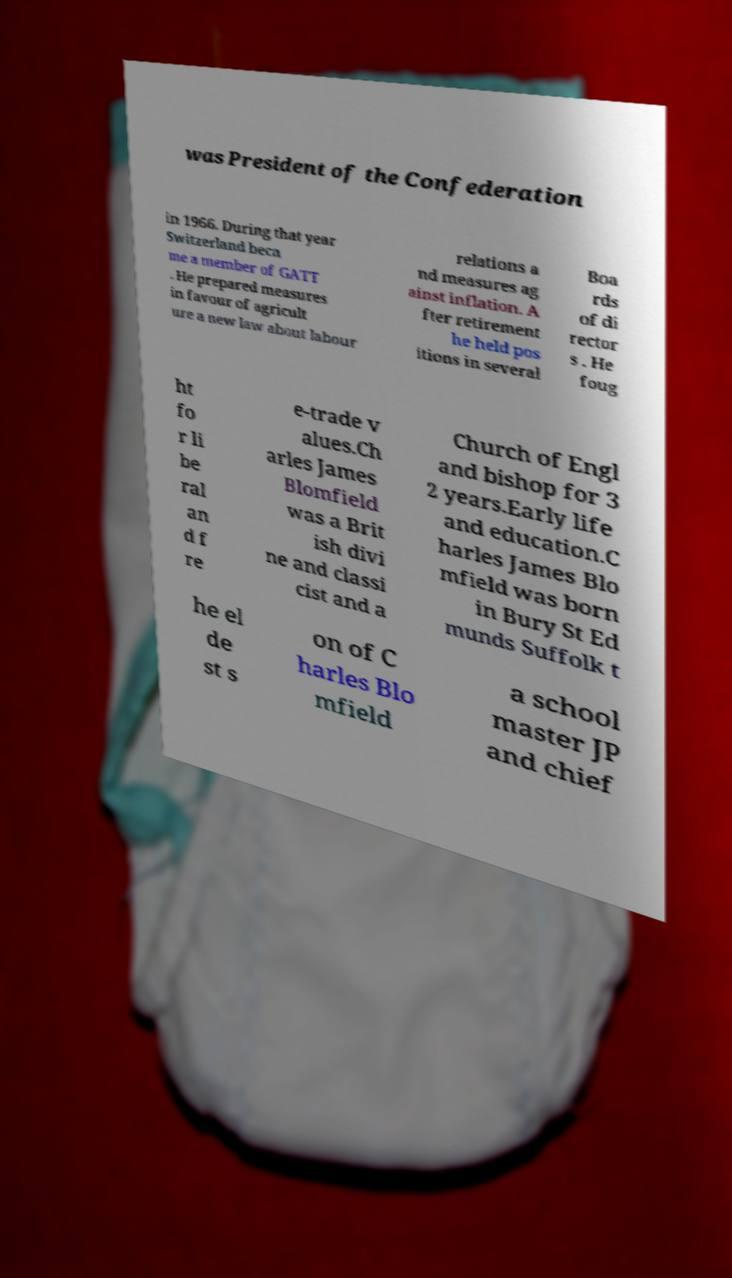Could you assist in decoding the text presented in this image and type it out clearly? was President of the Confederation in 1966. During that year Switzerland beca me a member of GATT . He prepared measures in favour of agricult ure a new law about labour relations a nd measures ag ainst inflation. A fter retirement he held pos itions in several Boa rds of di rector s . He foug ht fo r li be ral an d f re e-trade v alues.Ch arles James Blomfield was a Brit ish divi ne and classi cist and a Church of Engl and bishop for 3 2 years.Early life and education.C harles James Blo mfield was born in Bury St Ed munds Suffolk t he el de st s on of C harles Blo mfield a school master JP and chief 